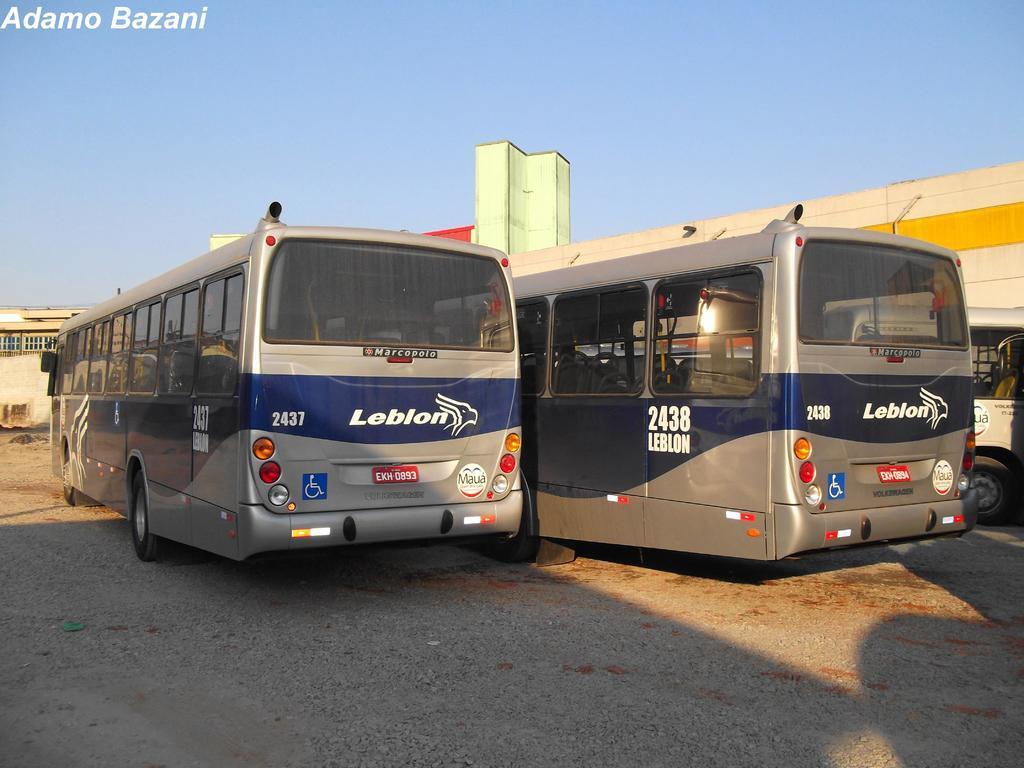In one or two sentences, can you explain what this image depicts? In this picture there are buses in the center of the image and there are buildings in the background area of the image, there is sky at the top side of the image. 